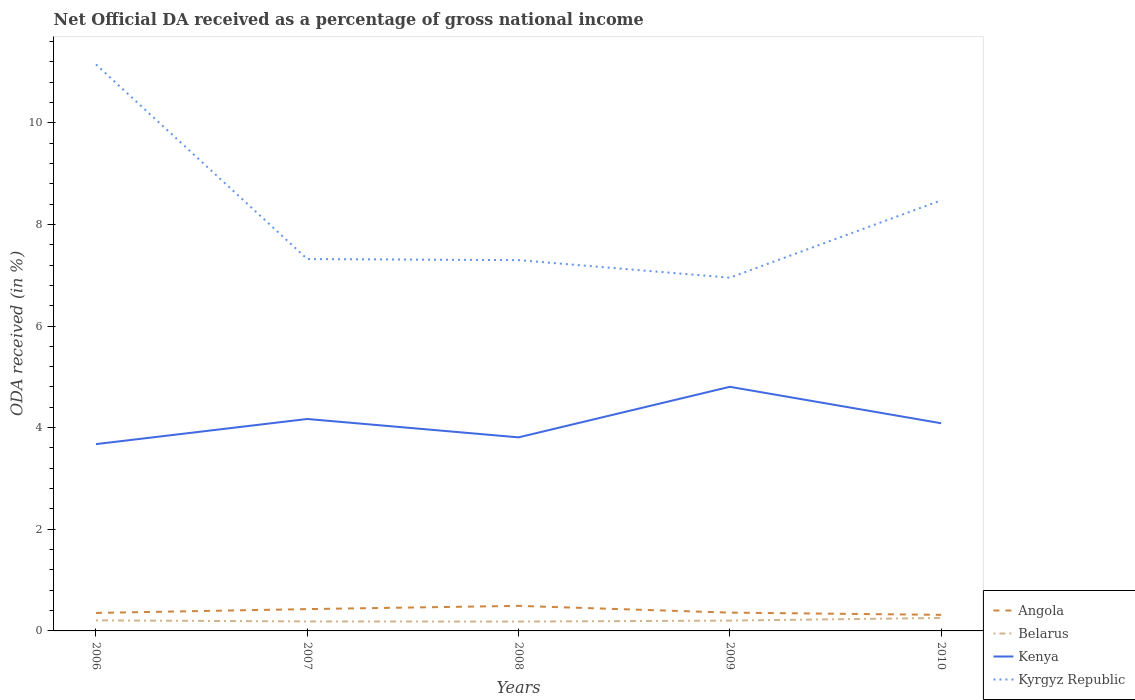Is the number of lines equal to the number of legend labels?
Your answer should be very brief. Yes. Across all years, what is the maximum net official DA received in Angola?
Provide a succinct answer. 0.32. In which year was the net official DA received in Belarus maximum?
Give a very brief answer. 2008. What is the total net official DA received in Angola in the graph?
Your answer should be very brief. -0.06. What is the difference between the highest and the second highest net official DA received in Angola?
Keep it short and to the point. 0.18. Is the net official DA received in Belarus strictly greater than the net official DA received in Kyrgyz Republic over the years?
Offer a very short reply. Yes. How many years are there in the graph?
Offer a very short reply. 5. What is the difference between two consecutive major ticks on the Y-axis?
Provide a short and direct response. 2. Are the values on the major ticks of Y-axis written in scientific E-notation?
Your response must be concise. No. Does the graph contain any zero values?
Your answer should be very brief. No. Does the graph contain grids?
Offer a terse response. No. What is the title of the graph?
Ensure brevity in your answer.  Net Official DA received as a percentage of gross national income. What is the label or title of the X-axis?
Provide a succinct answer. Years. What is the label or title of the Y-axis?
Keep it short and to the point. ODA received (in %). What is the ODA received (in %) of Angola in 2006?
Your response must be concise. 0.35. What is the ODA received (in %) of Belarus in 2006?
Offer a very short reply. 0.21. What is the ODA received (in %) of Kenya in 2006?
Your answer should be very brief. 3.68. What is the ODA received (in %) of Kyrgyz Republic in 2006?
Offer a terse response. 11.15. What is the ODA received (in %) in Angola in 2007?
Make the answer very short. 0.43. What is the ODA received (in %) of Belarus in 2007?
Give a very brief answer. 0.19. What is the ODA received (in %) in Kenya in 2007?
Keep it short and to the point. 4.17. What is the ODA received (in %) of Kyrgyz Republic in 2007?
Ensure brevity in your answer.  7.32. What is the ODA received (in %) in Angola in 2008?
Keep it short and to the point. 0.49. What is the ODA received (in %) in Belarus in 2008?
Ensure brevity in your answer.  0.18. What is the ODA received (in %) of Kenya in 2008?
Provide a succinct answer. 3.81. What is the ODA received (in %) in Kyrgyz Republic in 2008?
Provide a succinct answer. 7.3. What is the ODA received (in %) of Angola in 2009?
Give a very brief answer. 0.36. What is the ODA received (in %) in Belarus in 2009?
Keep it short and to the point. 0.2. What is the ODA received (in %) in Kenya in 2009?
Ensure brevity in your answer.  4.8. What is the ODA received (in %) of Kyrgyz Republic in 2009?
Make the answer very short. 6.95. What is the ODA received (in %) in Angola in 2010?
Give a very brief answer. 0.32. What is the ODA received (in %) in Belarus in 2010?
Your answer should be compact. 0.26. What is the ODA received (in %) of Kenya in 2010?
Make the answer very short. 4.09. What is the ODA received (in %) of Kyrgyz Republic in 2010?
Your response must be concise. 8.47. Across all years, what is the maximum ODA received (in %) of Angola?
Keep it short and to the point. 0.49. Across all years, what is the maximum ODA received (in %) of Belarus?
Your response must be concise. 0.26. Across all years, what is the maximum ODA received (in %) of Kenya?
Provide a short and direct response. 4.8. Across all years, what is the maximum ODA received (in %) in Kyrgyz Republic?
Your response must be concise. 11.15. Across all years, what is the minimum ODA received (in %) of Angola?
Offer a very short reply. 0.32. Across all years, what is the minimum ODA received (in %) of Belarus?
Offer a terse response. 0.18. Across all years, what is the minimum ODA received (in %) of Kenya?
Your answer should be compact. 3.68. Across all years, what is the minimum ODA received (in %) in Kyrgyz Republic?
Provide a short and direct response. 6.95. What is the total ODA received (in %) in Angola in the graph?
Offer a terse response. 1.95. What is the total ODA received (in %) of Belarus in the graph?
Provide a succinct answer. 1.04. What is the total ODA received (in %) of Kenya in the graph?
Provide a short and direct response. 20.55. What is the total ODA received (in %) of Kyrgyz Republic in the graph?
Make the answer very short. 41.18. What is the difference between the ODA received (in %) of Angola in 2006 and that in 2007?
Make the answer very short. -0.08. What is the difference between the ODA received (in %) of Belarus in 2006 and that in 2007?
Keep it short and to the point. 0.02. What is the difference between the ODA received (in %) in Kenya in 2006 and that in 2007?
Provide a short and direct response. -0.49. What is the difference between the ODA received (in %) of Kyrgyz Republic in 2006 and that in 2007?
Your answer should be very brief. 3.83. What is the difference between the ODA received (in %) of Angola in 2006 and that in 2008?
Give a very brief answer. -0.14. What is the difference between the ODA received (in %) in Belarus in 2006 and that in 2008?
Your response must be concise. 0.02. What is the difference between the ODA received (in %) of Kenya in 2006 and that in 2008?
Give a very brief answer. -0.13. What is the difference between the ODA received (in %) of Kyrgyz Republic in 2006 and that in 2008?
Give a very brief answer. 3.85. What is the difference between the ODA received (in %) in Angola in 2006 and that in 2009?
Your response must be concise. -0.01. What is the difference between the ODA received (in %) in Belarus in 2006 and that in 2009?
Provide a succinct answer. 0. What is the difference between the ODA received (in %) of Kenya in 2006 and that in 2009?
Provide a succinct answer. -1.13. What is the difference between the ODA received (in %) in Kyrgyz Republic in 2006 and that in 2009?
Provide a short and direct response. 4.2. What is the difference between the ODA received (in %) in Angola in 2006 and that in 2010?
Keep it short and to the point. 0.04. What is the difference between the ODA received (in %) in Belarus in 2006 and that in 2010?
Ensure brevity in your answer.  -0.05. What is the difference between the ODA received (in %) in Kenya in 2006 and that in 2010?
Your answer should be very brief. -0.41. What is the difference between the ODA received (in %) of Kyrgyz Republic in 2006 and that in 2010?
Offer a terse response. 2.67. What is the difference between the ODA received (in %) in Angola in 2007 and that in 2008?
Ensure brevity in your answer.  -0.06. What is the difference between the ODA received (in %) in Belarus in 2007 and that in 2008?
Ensure brevity in your answer.  0. What is the difference between the ODA received (in %) in Kenya in 2007 and that in 2008?
Offer a very short reply. 0.36. What is the difference between the ODA received (in %) in Kyrgyz Republic in 2007 and that in 2008?
Keep it short and to the point. 0.02. What is the difference between the ODA received (in %) in Angola in 2007 and that in 2009?
Your response must be concise. 0.07. What is the difference between the ODA received (in %) in Belarus in 2007 and that in 2009?
Your answer should be compact. -0.02. What is the difference between the ODA received (in %) in Kenya in 2007 and that in 2009?
Provide a short and direct response. -0.63. What is the difference between the ODA received (in %) of Kyrgyz Republic in 2007 and that in 2009?
Your answer should be compact. 0.37. What is the difference between the ODA received (in %) in Angola in 2007 and that in 2010?
Your answer should be very brief. 0.11. What is the difference between the ODA received (in %) of Belarus in 2007 and that in 2010?
Make the answer very short. -0.07. What is the difference between the ODA received (in %) in Kenya in 2007 and that in 2010?
Your response must be concise. 0.08. What is the difference between the ODA received (in %) in Kyrgyz Republic in 2007 and that in 2010?
Keep it short and to the point. -1.16. What is the difference between the ODA received (in %) in Angola in 2008 and that in 2009?
Keep it short and to the point. 0.13. What is the difference between the ODA received (in %) of Belarus in 2008 and that in 2009?
Ensure brevity in your answer.  -0.02. What is the difference between the ODA received (in %) in Kenya in 2008 and that in 2009?
Offer a terse response. -0.99. What is the difference between the ODA received (in %) of Kyrgyz Republic in 2008 and that in 2009?
Keep it short and to the point. 0.35. What is the difference between the ODA received (in %) of Angola in 2008 and that in 2010?
Your answer should be compact. 0.18. What is the difference between the ODA received (in %) of Belarus in 2008 and that in 2010?
Ensure brevity in your answer.  -0.07. What is the difference between the ODA received (in %) in Kenya in 2008 and that in 2010?
Your response must be concise. -0.28. What is the difference between the ODA received (in %) in Kyrgyz Republic in 2008 and that in 2010?
Ensure brevity in your answer.  -1.18. What is the difference between the ODA received (in %) of Angola in 2009 and that in 2010?
Offer a very short reply. 0.04. What is the difference between the ODA received (in %) of Belarus in 2009 and that in 2010?
Provide a short and direct response. -0.05. What is the difference between the ODA received (in %) of Kenya in 2009 and that in 2010?
Make the answer very short. 0.72. What is the difference between the ODA received (in %) in Kyrgyz Republic in 2009 and that in 2010?
Provide a succinct answer. -1.52. What is the difference between the ODA received (in %) of Angola in 2006 and the ODA received (in %) of Belarus in 2007?
Your answer should be very brief. 0.17. What is the difference between the ODA received (in %) in Angola in 2006 and the ODA received (in %) in Kenya in 2007?
Provide a succinct answer. -3.82. What is the difference between the ODA received (in %) in Angola in 2006 and the ODA received (in %) in Kyrgyz Republic in 2007?
Ensure brevity in your answer.  -6.96. What is the difference between the ODA received (in %) in Belarus in 2006 and the ODA received (in %) in Kenya in 2007?
Offer a very short reply. -3.96. What is the difference between the ODA received (in %) in Belarus in 2006 and the ODA received (in %) in Kyrgyz Republic in 2007?
Provide a succinct answer. -7.11. What is the difference between the ODA received (in %) in Kenya in 2006 and the ODA received (in %) in Kyrgyz Republic in 2007?
Provide a succinct answer. -3.64. What is the difference between the ODA received (in %) of Angola in 2006 and the ODA received (in %) of Belarus in 2008?
Give a very brief answer. 0.17. What is the difference between the ODA received (in %) of Angola in 2006 and the ODA received (in %) of Kenya in 2008?
Provide a short and direct response. -3.45. What is the difference between the ODA received (in %) in Angola in 2006 and the ODA received (in %) in Kyrgyz Republic in 2008?
Provide a succinct answer. -6.94. What is the difference between the ODA received (in %) in Belarus in 2006 and the ODA received (in %) in Kenya in 2008?
Provide a succinct answer. -3.6. What is the difference between the ODA received (in %) of Belarus in 2006 and the ODA received (in %) of Kyrgyz Republic in 2008?
Your answer should be very brief. -7.09. What is the difference between the ODA received (in %) in Kenya in 2006 and the ODA received (in %) in Kyrgyz Republic in 2008?
Provide a short and direct response. -3.62. What is the difference between the ODA received (in %) of Angola in 2006 and the ODA received (in %) of Belarus in 2009?
Make the answer very short. 0.15. What is the difference between the ODA received (in %) in Angola in 2006 and the ODA received (in %) in Kenya in 2009?
Keep it short and to the point. -4.45. What is the difference between the ODA received (in %) in Angola in 2006 and the ODA received (in %) in Kyrgyz Republic in 2009?
Provide a succinct answer. -6.6. What is the difference between the ODA received (in %) of Belarus in 2006 and the ODA received (in %) of Kenya in 2009?
Give a very brief answer. -4.6. What is the difference between the ODA received (in %) in Belarus in 2006 and the ODA received (in %) in Kyrgyz Republic in 2009?
Offer a terse response. -6.74. What is the difference between the ODA received (in %) in Kenya in 2006 and the ODA received (in %) in Kyrgyz Republic in 2009?
Keep it short and to the point. -3.27. What is the difference between the ODA received (in %) in Angola in 2006 and the ODA received (in %) in Belarus in 2010?
Ensure brevity in your answer.  0.1. What is the difference between the ODA received (in %) of Angola in 2006 and the ODA received (in %) of Kenya in 2010?
Your answer should be very brief. -3.73. What is the difference between the ODA received (in %) of Angola in 2006 and the ODA received (in %) of Kyrgyz Republic in 2010?
Give a very brief answer. -8.12. What is the difference between the ODA received (in %) of Belarus in 2006 and the ODA received (in %) of Kenya in 2010?
Provide a succinct answer. -3.88. What is the difference between the ODA received (in %) of Belarus in 2006 and the ODA received (in %) of Kyrgyz Republic in 2010?
Make the answer very short. -8.27. What is the difference between the ODA received (in %) in Kenya in 2006 and the ODA received (in %) in Kyrgyz Republic in 2010?
Provide a succinct answer. -4.8. What is the difference between the ODA received (in %) in Angola in 2007 and the ODA received (in %) in Belarus in 2008?
Your answer should be very brief. 0.25. What is the difference between the ODA received (in %) of Angola in 2007 and the ODA received (in %) of Kenya in 2008?
Keep it short and to the point. -3.38. What is the difference between the ODA received (in %) of Angola in 2007 and the ODA received (in %) of Kyrgyz Republic in 2008?
Provide a short and direct response. -6.87. What is the difference between the ODA received (in %) of Belarus in 2007 and the ODA received (in %) of Kenya in 2008?
Your answer should be very brief. -3.62. What is the difference between the ODA received (in %) of Belarus in 2007 and the ODA received (in %) of Kyrgyz Republic in 2008?
Provide a short and direct response. -7.11. What is the difference between the ODA received (in %) in Kenya in 2007 and the ODA received (in %) in Kyrgyz Republic in 2008?
Your answer should be compact. -3.13. What is the difference between the ODA received (in %) in Angola in 2007 and the ODA received (in %) in Belarus in 2009?
Offer a very short reply. 0.23. What is the difference between the ODA received (in %) in Angola in 2007 and the ODA received (in %) in Kenya in 2009?
Provide a short and direct response. -4.37. What is the difference between the ODA received (in %) in Angola in 2007 and the ODA received (in %) in Kyrgyz Republic in 2009?
Offer a terse response. -6.52. What is the difference between the ODA received (in %) of Belarus in 2007 and the ODA received (in %) of Kenya in 2009?
Your answer should be very brief. -4.62. What is the difference between the ODA received (in %) in Belarus in 2007 and the ODA received (in %) in Kyrgyz Republic in 2009?
Provide a short and direct response. -6.76. What is the difference between the ODA received (in %) of Kenya in 2007 and the ODA received (in %) of Kyrgyz Republic in 2009?
Provide a succinct answer. -2.78. What is the difference between the ODA received (in %) of Angola in 2007 and the ODA received (in %) of Belarus in 2010?
Offer a very short reply. 0.17. What is the difference between the ODA received (in %) in Angola in 2007 and the ODA received (in %) in Kenya in 2010?
Ensure brevity in your answer.  -3.66. What is the difference between the ODA received (in %) of Angola in 2007 and the ODA received (in %) of Kyrgyz Republic in 2010?
Your answer should be compact. -8.04. What is the difference between the ODA received (in %) of Belarus in 2007 and the ODA received (in %) of Kenya in 2010?
Offer a very short reply. -3.9. What is the difference between the ODA received (in %) in Belarus in 2007 and the ODA received (in %) in Kyrgyz Republic in 2010?
Keep it short and to the point. -8.29. What is the difference between the ODA received (in %) in Kenya in 2007 and the ODA received (in %) in Kyrgyz Republic in 2010?
Provide a succinct answer. -4.3. What is the difference between the ODA received (in %) of Angola in 2008 and the ODA received (in %) of Belarus in 2009?
Your answer should be very brief. 0.29. What is the difference between the ODA received (in %) of Angola in 2008 and the ODA received (in %) of Kenya in 2009?
Your response must be concise. -4.31. What is the difference between the ODA received (in %) in Angola in 2008 and the ODA received (in %) in Kyrgyz Republic in 2009?
Offer a very short reply. -6.46. What is the difference between the ODA received (in %) of Belarus in 2008 and the ODA received (in %) of Kenya in 2009?
Offer a very short reply. -4.62. What is the difference between the ODA received (in %) in Belarus in 2008 and the ODA received (in %) in Kyrgyz Republic in 2009?
Your answer should be very brief. -6.77. What is the difference between the ODA received (in %) of Kenya in 2008 and the ODA received (in %) of Kyrgyz Republic in 2009?
Give a very brief answer. -3.14. What is the difference between the ODA received (in %) of Angola in 2008 and the ODA received (in %) of Belarus in 2010?
Keep it short and to the point. 0.24. What is the difference between the ODA received (in %) in Angola in 2008 and the ODA received (in %) in Kenya in 2010?
Offer a very short reply. -3.59. What is the difference between the ODA received (in %) of Angola in 2008 and the ODA received (in %) of Kyrgyz Republic in 2010?
Offer a very short reply. -7.98. What is the difference between the ODA received (in %) in Belarus in 2008 and the ODA received (in %) in Kenya in 2010?
Ensure brevity in your answer.  -3.9. What is the difference between the ODA received (in %) in Belarus in 2008 and the ODA received (in %) in Kyrgyz Republic in 2010?
Offer a terse response. -8.29. What is the difference between the ODA received (in %) in Kenya in 2008 and the ODA received (in %) in Kyrgyz Republic in 2010?
Give a very brief answer. -4.66. What is the difference between the ODA received (in %) in Angola in 2009 and the ODA received (in %) in Belarus in 2010?
Make the answer very short. 0.1. What is the difference between the ODA received (in %) in Angola in 2009 and the ODA received (in %) in Kenya in 2010?
Keep it short and to the point. -3.73. What is the difference between the ODA received (in %) of Angola in 2009 and the ODA received (in %) of Kyrgyz Republic in 2010?
Your response must be concise. -8.11. What is the difference between the ODA received (in %) of Belarus in 2009 and the ODA received (in %) of Kenya in 2010?
Provide a short and direct response. -3.88. What is the difference between the ODA received (in %) in Belarus in 2009 and the ODA received (in %) in Kyrgyz Republic in 2010?
Provide a succinct answer. -8.27. What is the difference between the ODA received (in %) in Kenya in 2009 and the ODA received (in %) in Kyrgyz Republic in 2010?
Your response must be concise. -3.67. What is the average ODA received (in %) of Angola per year?
Make the answer very short. 0.39. What is the average ODA received (in %) of Belarus per year?
Offer a very short reply. 0.21. What is the average ODA received (in %) of Kenya per year?
Provide a short and direct response. 4.11. What is the average ODA received (in %) of Kyrgyz Republic per year?
Give a very brief answer. 8.24. In the year 2006, what is the difference between the ODA received (in %) of Angola and ODA received (in %) of Belarus?
Ensure brevity in your answer.  0.15. In the year 2006, what is the difference between the ODA received (in %) of Angola and ODA received (in %) of Kenya?
Ensure brevity in your answer.  -3.32. In the year 2006, what is the difference between the ODA received (in %) in Angola and ODA received (in %) in Kyrgyz Republic?
Ensure brevity in your answer.  -10.79. In the year 2006, what is the difference between the ODA received (in %) of Belarus and ODA received (in %) of Kenya?
Keep it short and to the point. -3.47. In the year 2006, what is the difference between the ODA received (in %) of Belarus and ODA received (in %) of Kyrgyz Republic?
Provide a succinct answer. -10.94. In the year 2006, what is the difference between the ODA received (in %) in Kenya and ODA received (in %) in Kyrgyz Republic?
Keep it short and to the point. -7.47. In the year 2007, what is the difference between the ODA received (in %) in Angola and ODA received (in %) in Belarus?
Make the answer very short. 0.24. In the year 2007, what is the difference between the ODA received (in %) of Angola and ODA received (in %) of Kenya?
Your answer should be compact. -3.74. In the year 2007, what is the difference between the ODA received (in %) in Angola and ODA received (in %) in Kyrgyz Republic?
Your answer should be very brief. -6.89. In the year 2007, what is the difference between the ODA received (in %) of Belarus and ODA received (in %) of Kenya?
Make the answer very short. -3.98. In the year 2007, what is the difference between the ODA received (in %) of Belarus and ODA received (in %) of Kyrgyz Republic?
Your answer should be very brief. -7.13. In the year 2007, what is the difference between the ODA received (in %) in Kenya and ODA received (in %) in Kyrgyz Republic?
Your response must be concise. -3.15. In the year 2008, what is the difference between the ODA received (in %) of Angola and ODA received (in %) of Belarus?
Provide a succinct answer. 0.31. In the year 2008, what is the difference between the ODA received (in %) of Angola and ODA received (in %) of Kenya?
Provide a succinct answer. -3.32. In the year 2008, what is the difference between the ODA received (in %) in Angola and ODA received (in %) in Kyrgyz Republic?
Your response must be concise. -6.8. In the year 2008, what is the difference between the ODA received (in %) of Belarus and ODA received (in %) of Kenya?
Your answer should be very brief. -3.62. In the year 2008, what is the difference between the ODA received (in %) in Belarus and ODA received (in %) in Kyrgyz Republic?
Your answer should be compact. -7.11. In the year 2008, what is the difference between the ODA received (in %) of Kenya and ODA received (in %) of Kyrgyz Republic?
Ensure brevity in your answer.  -3.49. In the year 2009, what is the difference between the ODA received (in %) of Angola and ODA received (in %) of Belarus?
Your answer should be very brief. 0.16. In the year 2009, what is the difference between the ODA received (in %) of Angola and ODA received (in %) of Kenya?
Your response must be concise. -4.44. In the year 2009, what is the difference between the ODA received (in %) in Angola and ODA received (in %) in Kyrgyz Republic?
Provide a succinct answer. -6.59. In the year 2009, what is the difference between the ODA received (in %) of Belarus and ODA received (in %) of Kenya?
Provide a succinct answer. -4.6. In the year 2009, what is the difference between the ODA received (in %) in Belarus and ODA received (in %) in Kyrgyz Republic?
Keep it short and to the point. -6.75. In the year 2009, what is the difference between the ODA received (in %) of Kenya and ODA received (in %) of Kyrgyz Republic?
Provide a succinct answer. -2.15. In the year 2010, what is the difference between the ODA received (in %) of Angola and ODA received (in %) of Belarus?
Keep it short and to the point. 0.06. In the year 2010, what is the difference between the ODA received (in %) of Angola and ODA received (in %) of Kenya?
Provide a succinct answer. -3.77. In the year 2010, what is the difference between the ODA received (in %) of Angola and ODA received (in %) of Kyrgyz Republic?
Give a very brief answer. -8.16. In the year 2010, what is the difference between the ODA received (in %) of Belarus and ODA received (in %) of Kenya?
Offer a terse response. -3.83. In the year 2010, what is the difference between the ODA received (in %) in Belarus and ODA received (in %) in Kyrgyz Republic?
Your answer should be very brief. -8.22. In the year 2010, what is the difference between the ODA received (in %) of Kenya and ODA received (in %) of Kyrgyz Republic?
Your response must be concise. -4.39. What is the ratio of the ODA received (in %) of Angola in 2006 to that in 2007?
Your response must be concise. 0.82. What is the ratio of the ODA received (in %) of Belarus in 2006 to that in 2007?
Provide a short and direct response. 1.11. What is the ratio of the ODA received (in %) in Kenya in 2006 to that in 2007?
Offer a terse response. 0.88. What is the ratio of the ODA received (in %) of Kyrgyz Republic in 2006 to that in 2007?
Give a very brief answer. 1.52. What is the ratio of the ODA received (in %) of Angola in 2006 to that in 2008?
Give a very brief answer. 0.72. What is the ratio of the ODA received (in %) of Belarus in 2006 to that in 2008?
Your answer should be compact. 1.13. What is the ratio of the ODA received (in %) in Kenya in 2006 to that in 2008?
Provide a short and direct response. 0.97. What is the ratio of the ODA received (in %) in Kyrgyz Republic in 2006 to that in 2008?
Offer a terse response. 1.53. What is the ratio of the ODA received (in %) of Angola in 2006 to that in 2009?
Your answer should be very brief. 0.98. What is the ratio of the ODA received (in %) in Belarus in 2006 to that in 2009?
Offer a very short reply. 1.02. What is the ratio of the ODA received (in %) in Kenya in 2006 to that in 2009?
Make the answer very short. 0.77. What is the ratio of the ODA received (in %) of Kyrgyz Republic in 2006 to that in 2009?
Make the answer very short. 1.6. What is the ratio of the ODA received (in %) in Angola in 2006 to that in 2010?
Provide a succinct answer. 1.12. What is the ratio of the ODA received (in %) in Belarus in 2006 to that in 2010?
Offer a terse response. 0.81. What is the ratio of the ODA received (in %) in Kenya in 2006 to that in 2010?
Give a very brief answer. 0.9. What is the ratio of the ODA received (in %) of Kyrgyz Republic in 2006 to that in 2010?
Offer a very short reply. 1.32. What is the ratio of the ODA received (in %) of Angola in 2007 to that in 2008?
Your answer should be compact. 0.87. What is the ratio of the ODA received (in %) in Belarus in 2007 to that in 2008?
Provide a short and direct response. 1.01. What is the ratio of the ODA received (in %) in Kenya in 2007 to that in 2008?
Ensure brevity in your answer.  1.09. What is the ratio of the ODA received (in %) of Kyrgyz Republic in 2007 to that in 2008?
Give a very brief answer. 1. What is the ratio of the ODA received (in %) in Angola in 2007 to that in 2009?
Your answer should be very brief. 1.19. What is the ratio of the ODA received (in %) of Belarus in 2007 to that in 2009?
Your response must be concise. 0.92. What is the ratio of the ODA received (in %) in Kenya in 2007 to that in 2009?
Your response must be concise. 0.87. What is the ratio of the ODA received (in %) in Kyrgyz Republic in 2007 to that in 2009?
Give a very brief answer. 1.05. What is the ratio of the ODA received (in %) of Angola in 2007 to that in 2010?
Your answer should be very brief. 1.36. What is the ratio of the ODA received (in %) of Belarus in 2007 to that in 2010?
Keep it short and to the point. 0.73. What is the ratio of the ODA received (in %) of Kenya in 2007 to that in 2010?
Keep it short and to the point. 1.02. What is the ratio of the ODA received (in %) of Kyrgyz Republic in 2007 to that in 2010?
Keep it short and to the point. 0.86. What is the ratio of the ODA received (in %) in Angola in 2008 to that in 2009?
Make the answer very short. 1.37. What is the ratio of the ODA received (in %) of Belarus in 2008 to that in 2009?
Your answer should be compact. 0.91. What is the ratio of the ODA received (in %) of Kenya in 2008 to that in 2009?
Ensure brevity in your answer.  0.79. What is the ratio of the ODA received (in %) in Kyrgyz Republic in 2008 to that in 2009?
Keep it short and to the point. 1.05. What is the ratio of the ODA received (in %) in Angola in 2008 to that in 2010?
Offer a terse response. 1.56. What is the ratio of the ODA received (in %) in Belarus in 2008 to that in 2010?
Make the answer very short. 0.72. What is the ratio of the ODA received (in %) of Kenya in 2008 to that in 2010?
Offer a very short reply. 0.93. What is the ratio of the ODA received (in %) in Kyrgyz Republic in 2008 to that in 2010?
Offer a very short reply. 0.86. What is the ratio of the ODA received (in %) in Angola in 2009 to that in 2010?
Give a very brief answer. 1.14. What is the ratio of the ODA received (in %) of Belarus in 2009 to that in 2010?
Give a very brief answer. 0.79. What is the ratio of the ODA received (in %) of Kenya in 2009 to that in 2010?
Your response must be concise. 1.18. What is the ratio of the ODA received (in %) of Kyrgyz Republic in 2009 to that in 2010?
Offer a terse response. 0.82. What is the difference between the highest and the second highest ODA received (in %) of Angola?
Keep it short and to the point. 0.06. What is the difference between the highest and the second highest ODA received (in %) of Belarus?
Your answer should be very brief. 0.05. What is the difference between the highest and the second highest ODA received (in %) of Kenya?
Offer a very short reply. 0.63. What is the difference between the highest and the second highest ODA received (in %) of Kyrgyz Republic?
Provide a succinct answer. 2.67. What is the difference between the highest and the lowest ODA received (in %) in Angola?
Make the answer very short. 0.18. What is the difference between the highest and the lowest ODA received (in %) in Belarus?
Your answer should be compact. 0.07. What is the difference between the highest and the lowest ODA received (in %) in Kenya?
Provide a succinct answer. 1.13. What is the difference between the highest and the lowest ODA received (in %) in Kyrgyz Republic?
Make the answer very short. 4.2. 